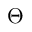<formula> <loc_0><loc_0><loc_500><loc_500>\Theta</formula> 